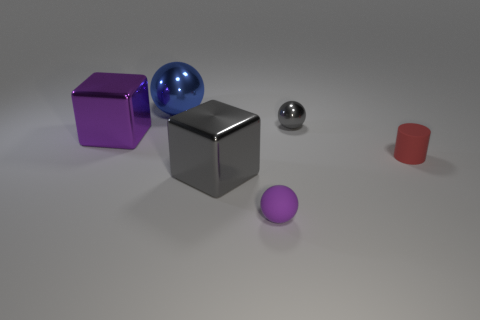How many other things are the same shape as the small gray shiny object?
Offer a terse response. 2. Is there a small purple rubber ball behind the gray thing that is right of the tiny rubber ball?
Your answer should be very brief. No. Is the shape of the purple metallic object the same as the gray thing that is behind the tiny red matte cylinder?
Offer a very short reply. No. There is a object that is both right of the tiny rubber ball and behind the red matte object; how big is it?
Your answer should be very brief. Small. Are there any tiny gray spheres that have the same material as the small purple ball?
Keep it short and to the point. No. What is the size of the metallic thing that is the same color as the small matte sphere?
Give a very brief answer. Large. There is a gray object to the left of the tiny sphere in front of the cylinder; what is its material?
Keep it short and to the point. Metal. How many large metallic objects have the same color as the tiny shiny sphere?
Give a very brief answer. 1. There is a red cylinder that is made of the same material as the small purple ball; what size is it?
Ensure brevity in your answer.  Small. The big metal thing that is on the left side of the large blue ball has what shape?
Give a very brief answer. Cube. 